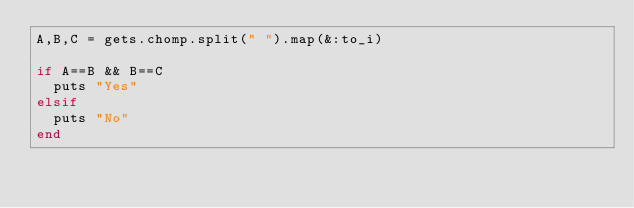Convert code to text. <code><loc_0><loc_0><loc_500><loc_500><_Ruby_>A,B,C = gets.chomp.split(" ").map(&:to_i)

if A==B && B==C
  puts "Yes"
elsif
  puts "No"
end</code> 